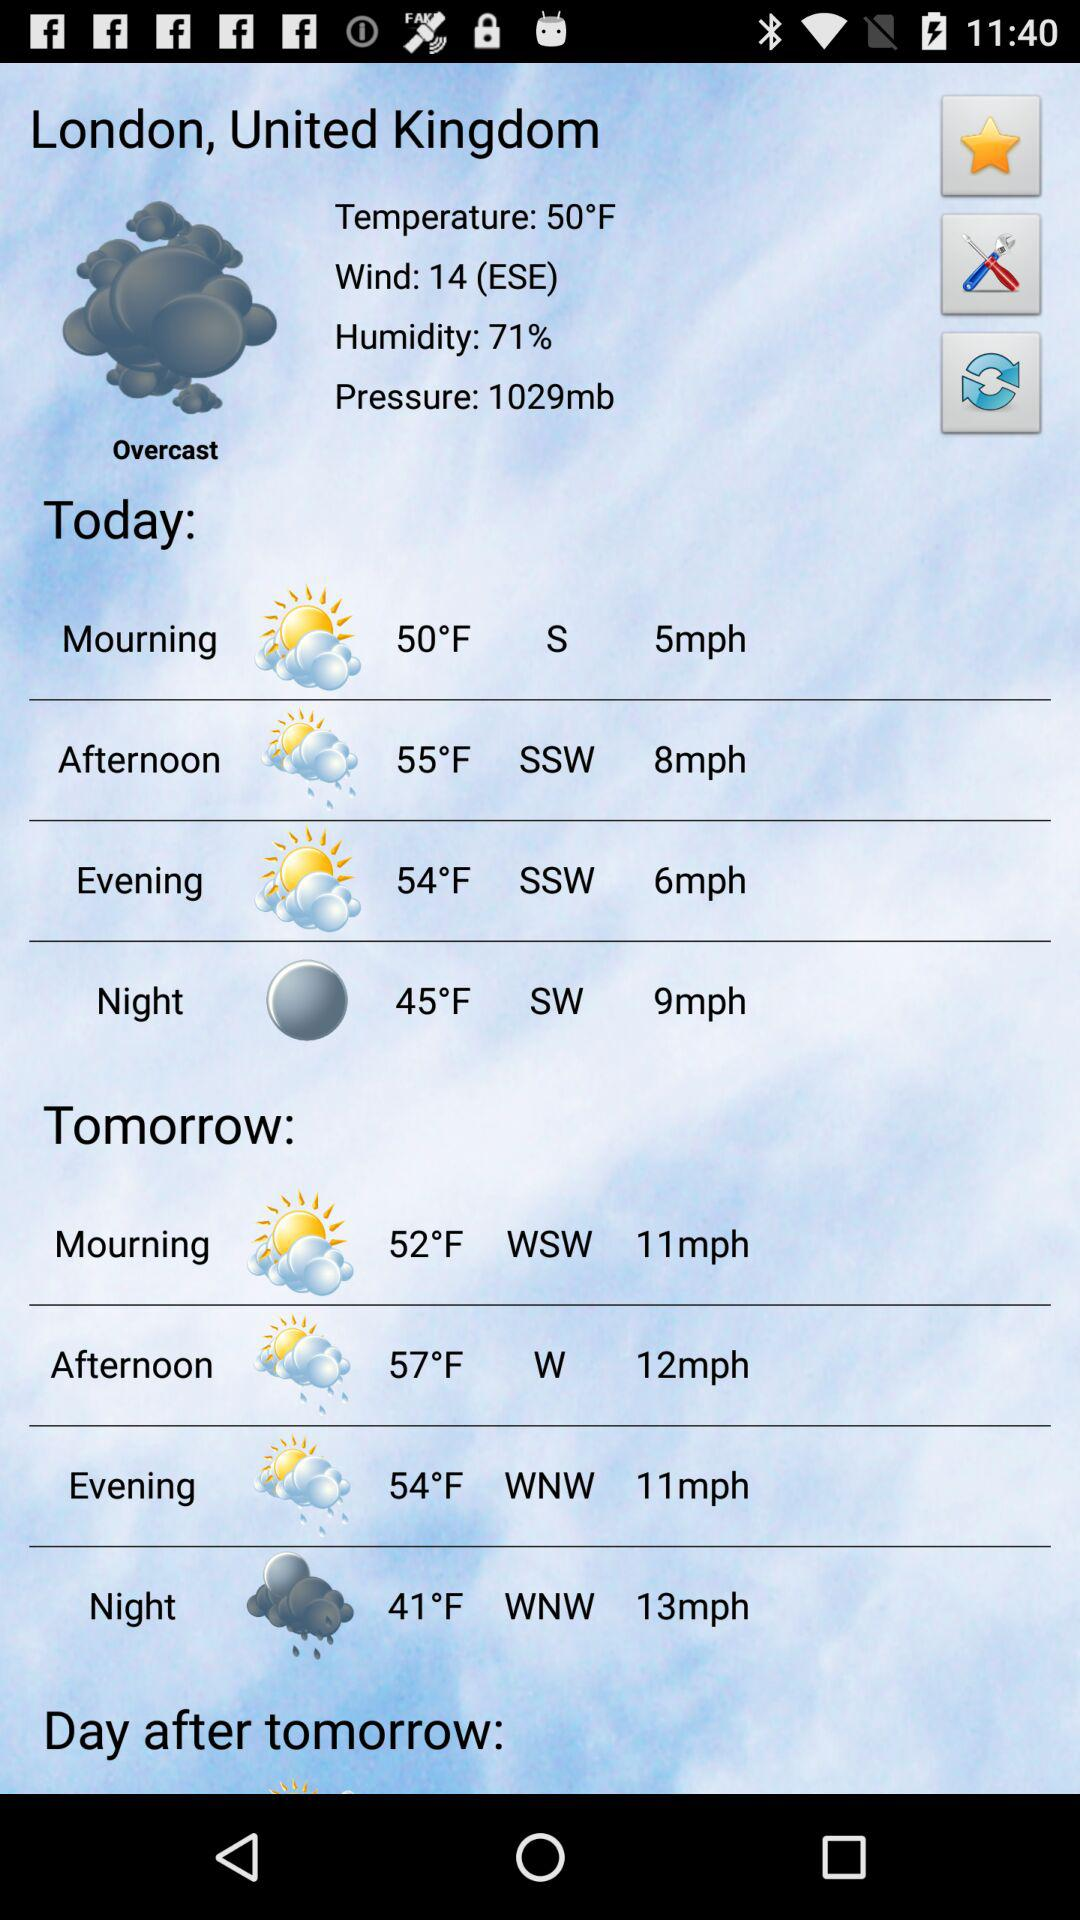What will the wind speed be tomorrow afternoon in London, United Kingdom? The wind speed will be 12 mph. 